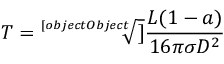Convert formula to latex. <formula><loc_0><loc_0><loc_500><loc_500>T = { \sqrt { [ } [ o b j e c t O b j e c t ] ] { \frac { L ( 1 - a ) } { 1 6 \pi \sigma D ^ { 2 } } } }</formula> 